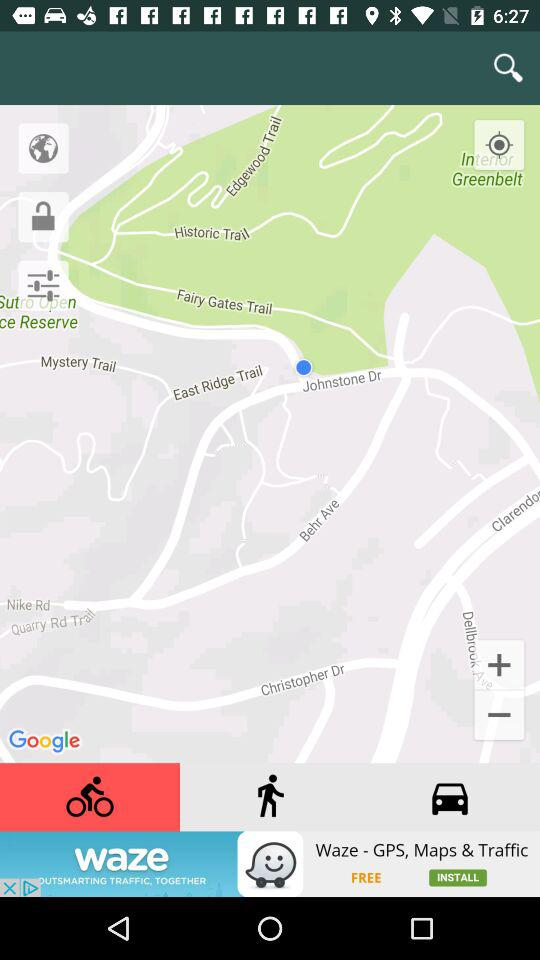How much is the given latitude? The given latitude is 37.7588861. 